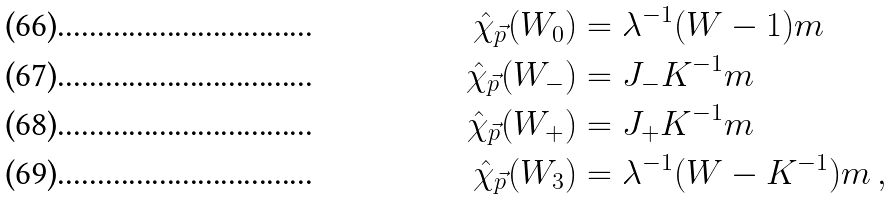<formula> <loc_0><loc_0><loc_500><loc_500>\hat { \chi } _ { \vec { p } } ( W _ { 0 } ) & = \lambda ^ { - 1 } ( W - 1 ) m \\ \hat { \chi } _ { \vec { p } } ( W _ { - } ) & = J _ { - } K ^ { - 1 } m \\ \hat { \chi } _ { \vec { p } } ( W _ { + } ) & = J _ { + } K ^ { - 1 } m \\ \hat { \chi } _ { \vec { p } } ( W _ { 3 } ) & = \lambda ^ { - 1 } ( W - K ^ { - 1 } ) m \, ,</formula> 